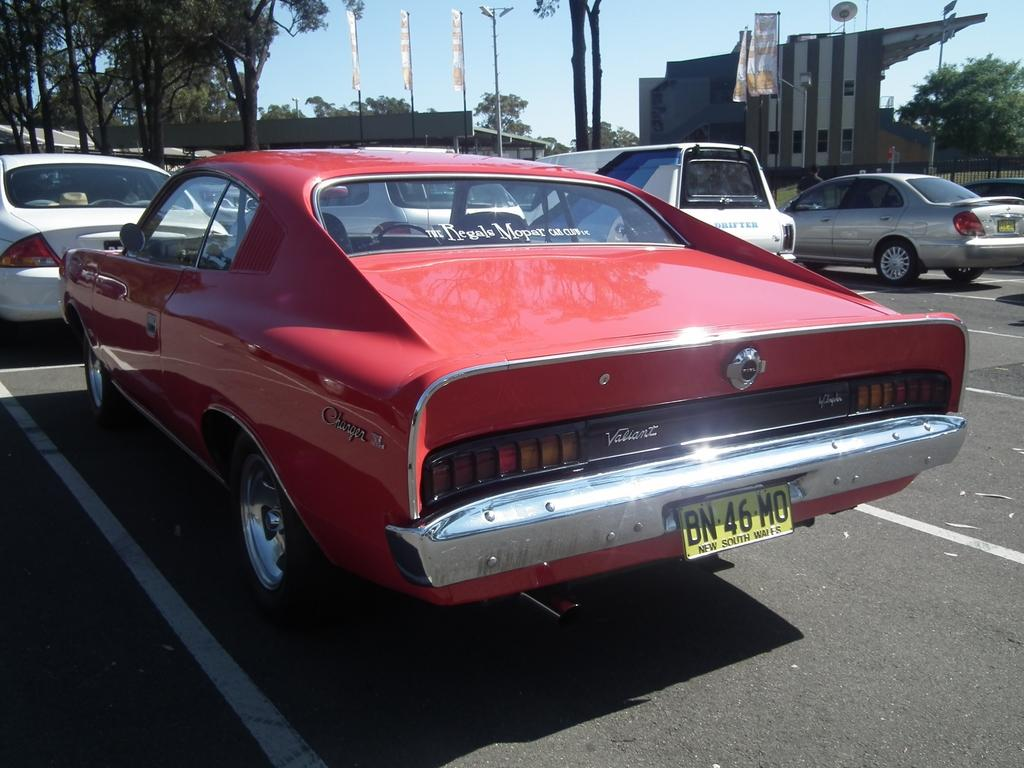<image>
Offer a succinct explanation of the picture presented. a car with a BN license plate on the back 